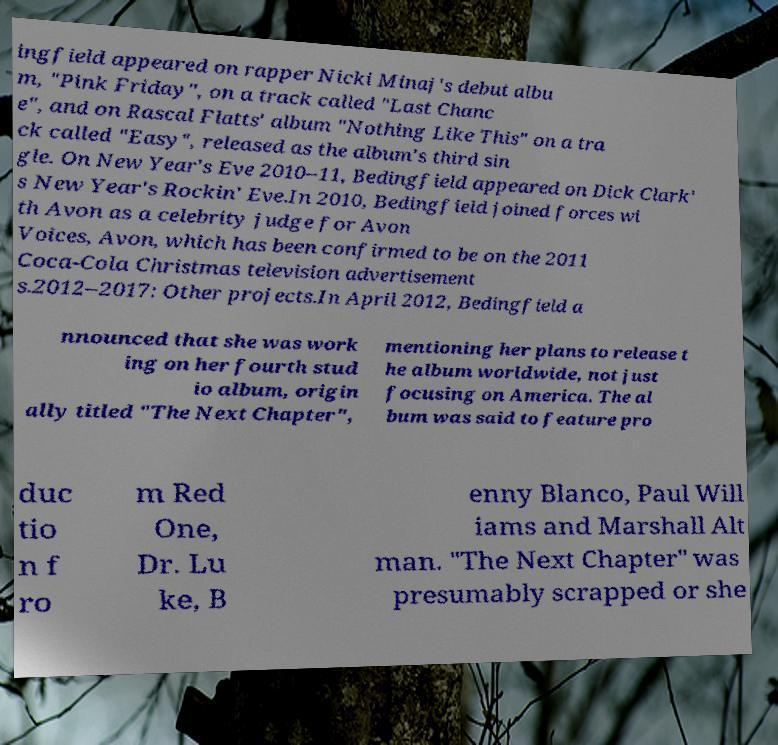What messages or text are displayed in this image? I need them in a readable, typed format. ingfield appeared on rapper Nicki Minaj's debut albu m, "Pink Friday", on a track called "Last Chanc e", and on Rascal Flatts' album "Nothing Like This" on a tra ck called "Easy", released as the album's third sin gle. On New Year's Eve 2010–11, Bedingfield appeared on Dick Clark' s New Year's Rockin' Eve.In 2010, Bedingfield joined forces wi th Avon as a celebrity judge for Avon Voices, Avon, which has been confirmed to be on the 2011 Coca-Cola Christmas television advertisement s.2012–2017: Other projects.In April 2012, Bedingfield a nnounced that she was work ing on her fourth stud io album, origin ally titled "The Next Chapter", mentioning her plans to release t he album worldwide, not just focusing on America. The al bum was said to feature pro duc tio n f ro m Red One, Dr. Lu ke, B enny Blanco, Paul Will iams and Marshall Alt man. "The Next Chapter" was presumably scrapped or she 